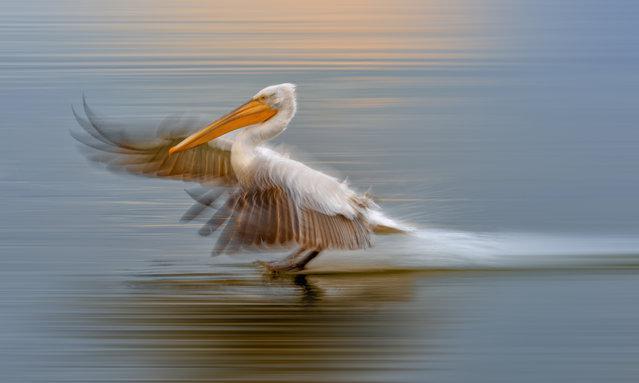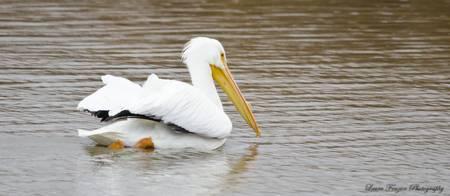The first image is the image on the left, the second image is the image on the right. Examine the images to the left and right. Is the description "The left image shows two pelicans on the water." accurate? Answer yes or no. No. 